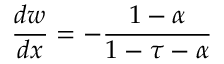<formula> <loc_0><loc_0><loc_500><loc_500>{ \frac { d w } { d x } } = - { \frac { 1 - \alpha } { 1 - \tau - \alpha } }</formula> 